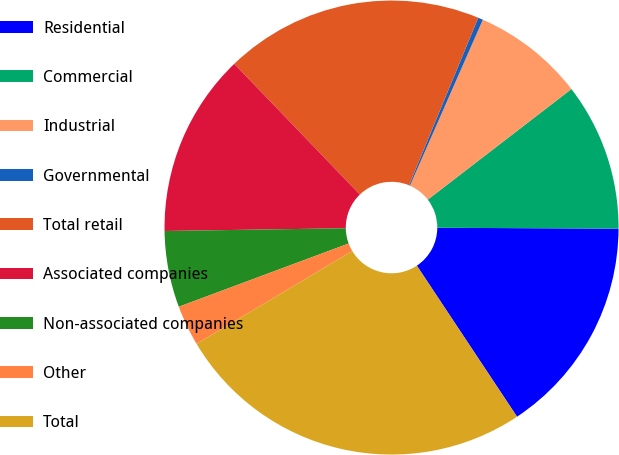Convert chart to OTSL. <chart><loc_0><loc_0><loc_500><loc_500><pie_chart><fcel>Residential<fcel>Commercial<fcel>Industrial<fcel>Governmental<fcel>Total retail<fcel>Associated companies<fcel>Non-associated companies<fcel>Other<fcel>Total<nl><fcel>15.6%<fcel>10.52%<fcel>7.97%<fcel>0.35%<fcel>18.42%<fcel>13.06%<fcel>5.43%<fcel>2.89%<fcel>25.76%<nl></chart> 